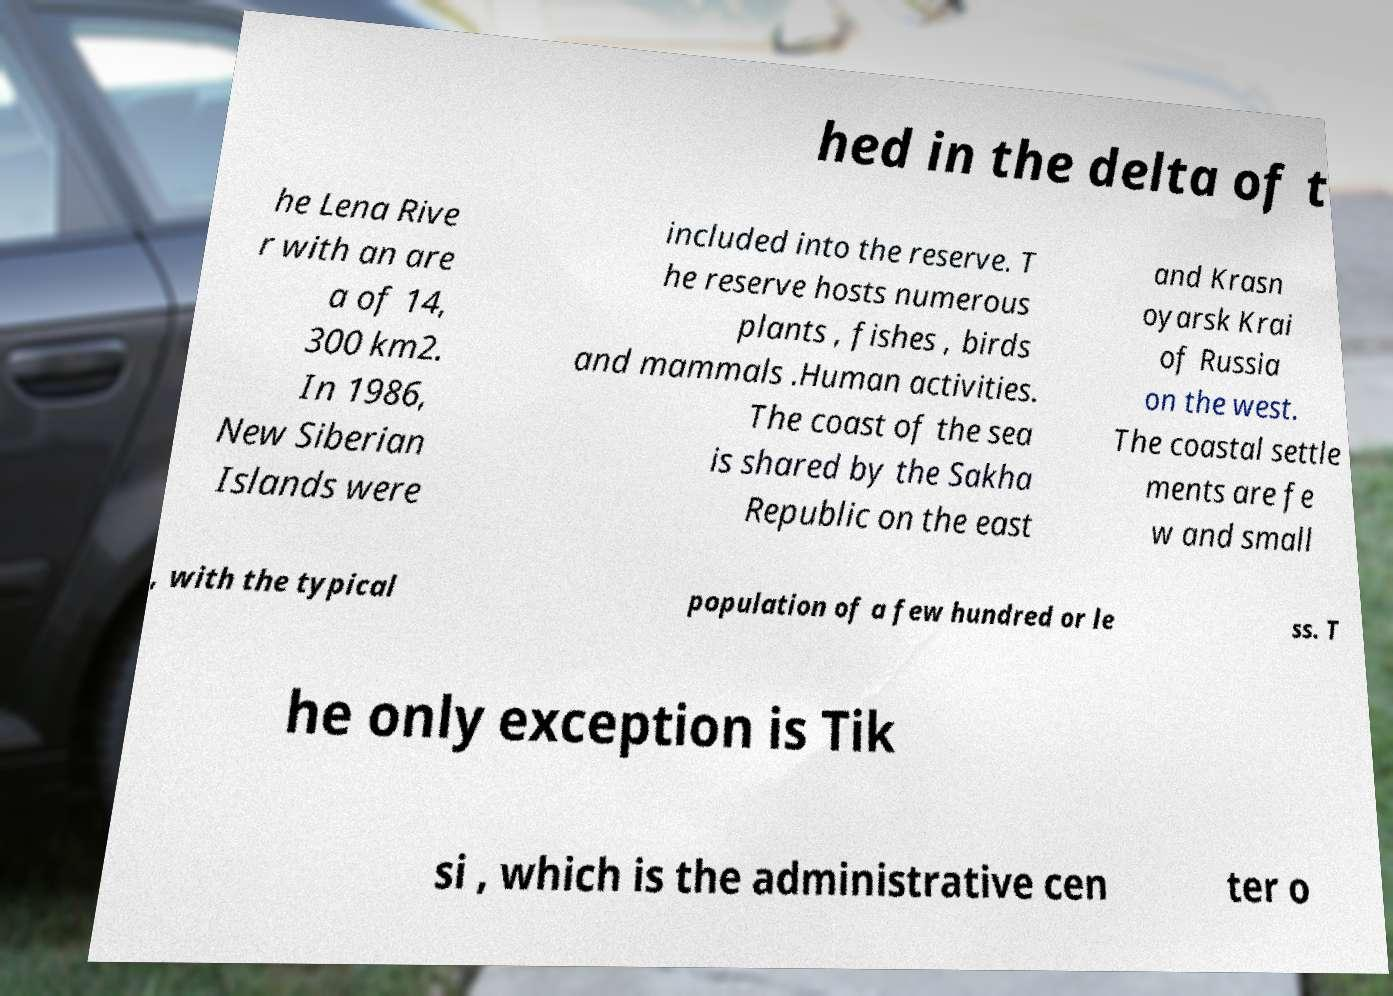Could you extract and type out the text from this image? hed in the delta of t he Lena Rive r with an are a of 14, 300 km2. In 1986, New Siberian Islands were included into the reserve. T he reserve hosts numerous plants , fishes , birds and mammals .Human activities. The coast of the sea is shared by the Sakha Republic on the east and Krasn oyarsk Krai of Russia on the west. The coastal settle ments are fe w and small , with the typical population of a few hundred or le ss. T he only exception is Tik si , which is the administrative cen ter o 